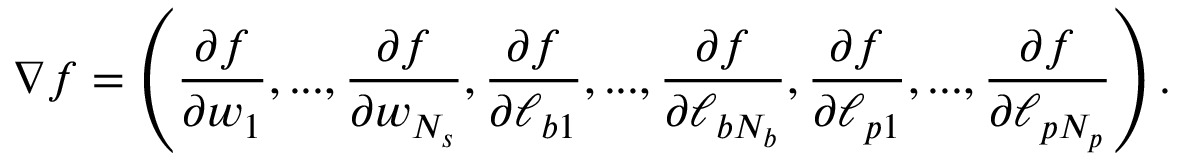<formula> <loc_0><loc_0><loc_500><loc_500>\nabla f = \left ( \frac { \partial f } { \partial w _ { 1 } } , \dots , \frac { \partial f } { \partial w _ { N _ { s } } } , \frac { \partial f } { \partial \ell _ { b 1 } } , \dots , \frac { \partial f } { \partial \ell _ { b N _ { b } } } , \frac { \partial f } { \partial \ell _ { p 1 } } , \dots , \frac { \partial f } { \partial \ell _ { p N _ { p } } } \right ) .</formula> 